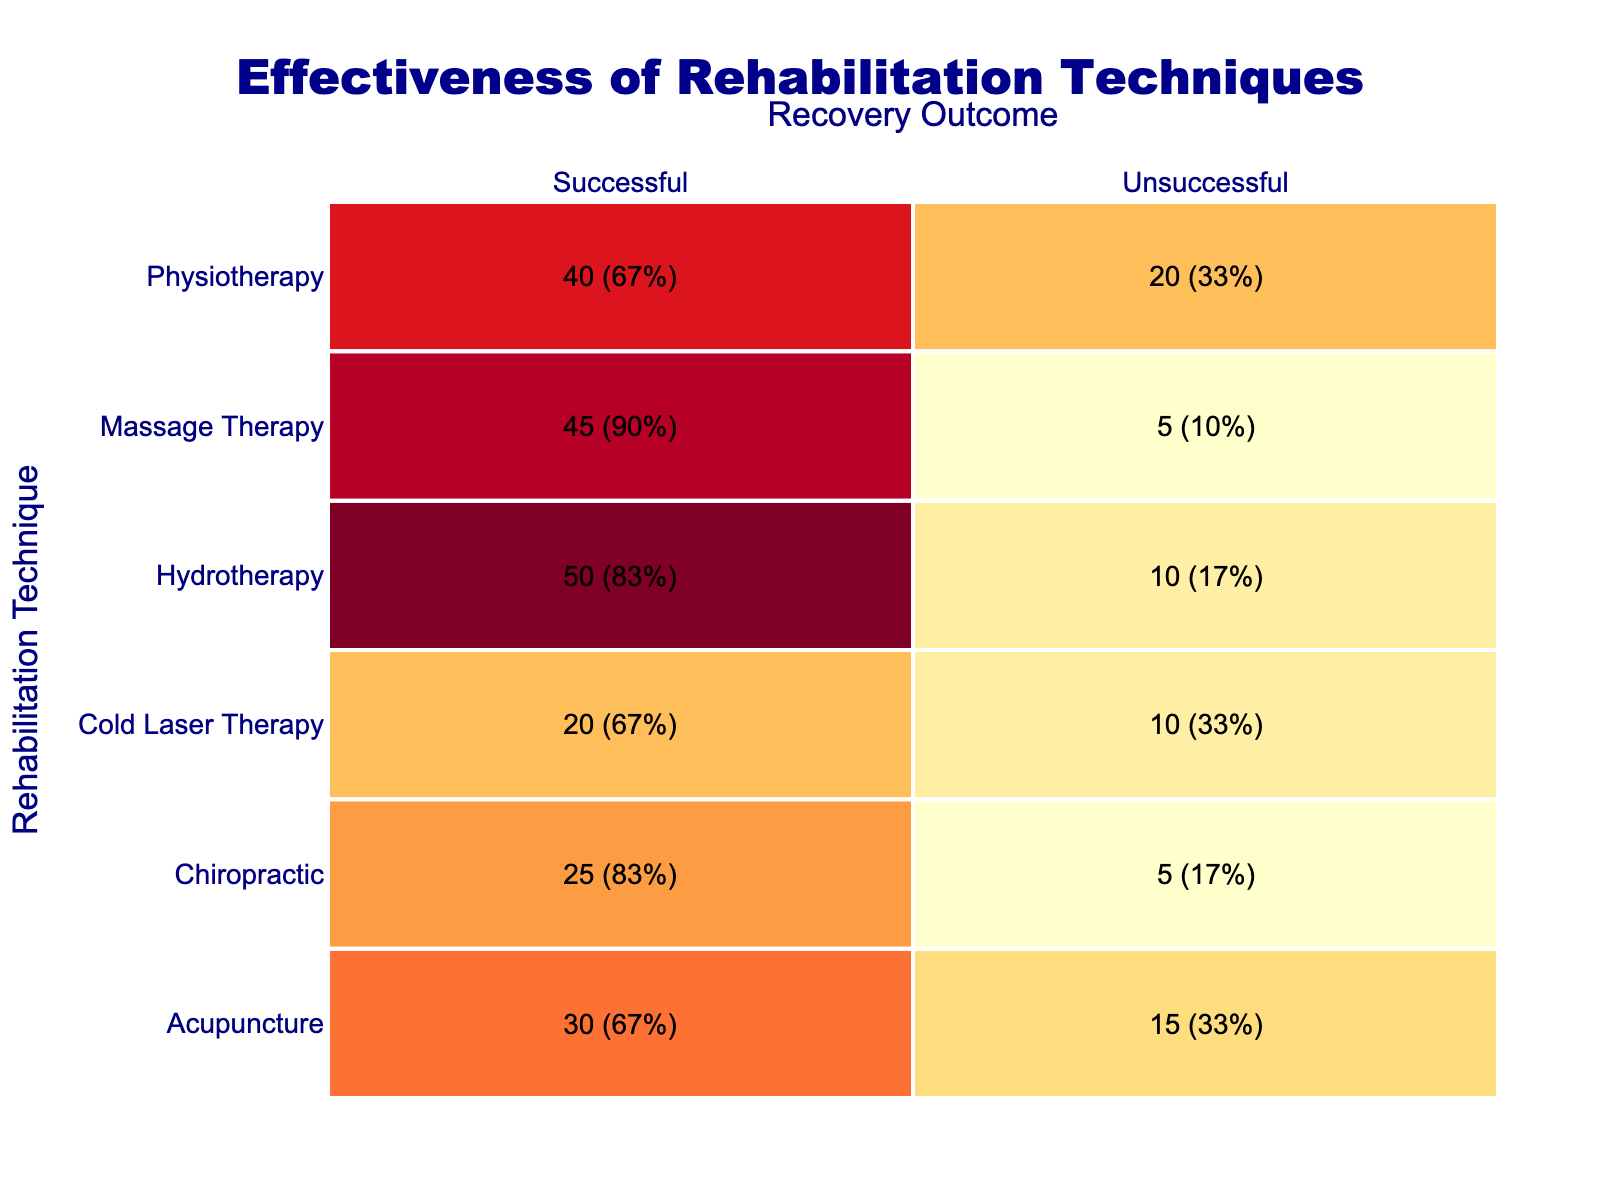What is the total count of successful recovery outcomes across all rehabilitation techniques? To find the total count of successful outcomes, we need to add the successful counts from all techniques: Hydrotherapy (50) + Physiotherapy (40) + Acupuncture (30) + Chiropractic (25) + Massage Therapy (45) + Cold Laser Therapy (20) = 210.
Answer: 210 Which rehabilitation technique had the highest count of unsuccessful recovery outcomes? Looking at the unsuccessful counts, Hydrotherapy has 10, Physiotherapy has 20, Acupuncture has 15, Chiropractic has 5, Massage Therapy has 5, and Cold Laser Therapy has 10. The highest count is 20 from Physiotherapy.
Answer: Physiotherapy Is it true that Acupuncture had more successful outcomes than Chiropractic? Acupuncture had 30 successful outcomes while Chiropractic had 25. Since 30 is greater than 25, the statement is true.
Answer: Yes What is the success rate for Massage Therapy calculated as a percentage? To calculate the success rate for Massage Therapy, we divide the successful outcomes (45) by the total (successful + unsuccessful: 45 + 5 = 50), which gives 45/50 = 0.9. Multiplying by 100 gives us a success rate of 90%.
Answer: 90% What is the difference in successful recovery outcomes between Hydrotherapy and Massage Therapy? Hydrotherapy had 50 successful outcomes and Massage Therapy had 45. The difference is 50 - 45 = 5.
Answer: 5 Which technique had the lowest percentage of successful recovery outcomes? First, we calculate the success rates for each technique based on the formula: (successful outcomes / total outcomes) * 100. For all techniques: Hydrotherapy = 83.3%, Physiotherapy = 66.7%, Acupuncture = 66.7%, Chiropractic = 83.3%, Massage Therapy = 90%, Cold Laser Therapy = 66.7%. The lowest is 66.7% shared by Physiotherapy, Acupuncture, and Cold Laser Therapy.
Answer: Physiotherapy, Acupuncture, Cold Laser Therapy How many total counts were recorded for Chiropractic rehabilitation techniques? The total counts for Chiropractic are: Successful (25) + Unsuccessful (5) = 30.
Answer: 30 Which rehabilitation technique had a success rate of 75% or higher? For each technique, we compute the success rates. The following techniques had 75% or greater success: Hydrotherapy (83.3%), Chiropractic (83.3%), and Massage Therapy (90%). Hence, the answer comprises these techniques.
Answer: Hydrotherapy, Chiropractic, Massage Therapy 